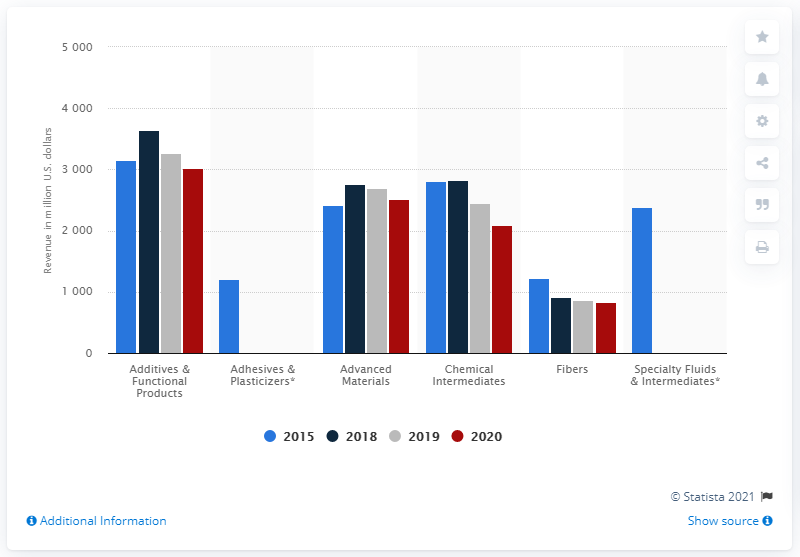Highlight a few significant elements in this photo. In 2020, the fibers segment of Eastman Chemical Company generated approximately 837 million in revenue. 